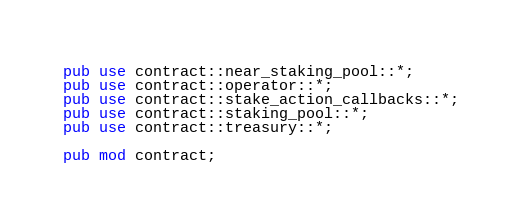Convert code to text. <code><loc_0><loc_0><loc_500><loc_500><_Rust_>pub use contract::near_staking_pool::*;
pub use contract::operator::*;
pub use contract::stake_action_callbacks::*;
pub use contract::staking_pool::*;
pub use contract::treasury::*;

pub mod contract;
</code> 